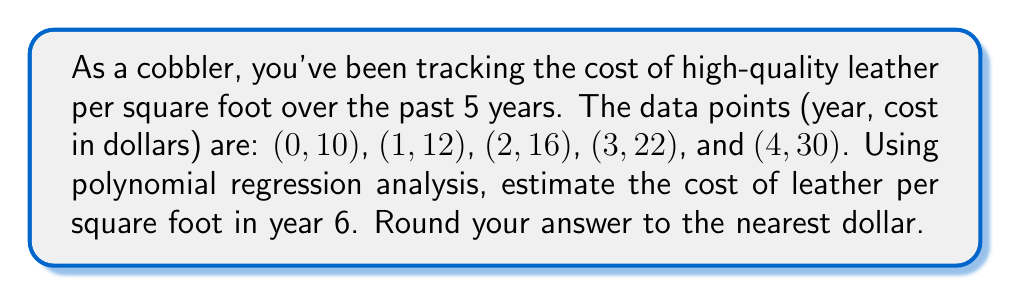Can you answer this question? 1) Given the data points, we'll use a second-degree polynomial regression: $y = ax^2 + bx + c$

2) We need to solve the following system of equations:
   $$\begin{cases}
   10 = c \\
   12 = a + b + c \\
   16 = 4a + 2b + c \\
   22 = 9a + 3b + c \\
   30 = 16a + 4b + c
   \end{cases}$$

3) From the first equation, we know $c = 10$

4) Subtracting the first equation from the others:
   $$\begin{cases}
   2 = a + b \\
   6 = 4a + 2b \\
   12 = 9a + 3b \\
   20 = 16a + 4b
   \end{cases}$$

5) From the first of these: $b = 2 - a$

6) Substituting this into the second equation:
   $6 = 4a + 2(2-a) = 4a + 4 - 2a = 2a + 4$
   $2 = 2a$
   $a = 1$

7) Since $a = 1$, we can deduce $b = 1$ as well

8) Our polynomial is therefore: $y = x^2 + x + 10$

9) To estimate the cost in year 6, we substitute $x = 6$:
   $y = 6^2 + 6 + 10 = 36 + 6 + 10 = 52$

10) Rounding to the nearest dollar: 52
Answer: $52 